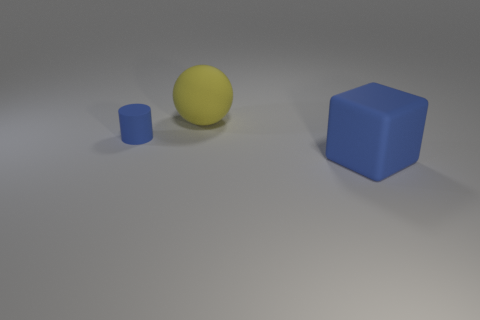Add 1 small blue cylinders. How many objects exist? 4 Subtract all cubes. How many objects are left? 2 Subtract 0 red cylinders. How many objects are left? 3 Subtract all tiny green metallic objects. Subtract all yellow things. How many objects are left? 2 Add 2 blue cubes. How many blue cubes are left? 3 Add 2 large purple rubber cubes. How many large purple rubber cubes exist? 2 